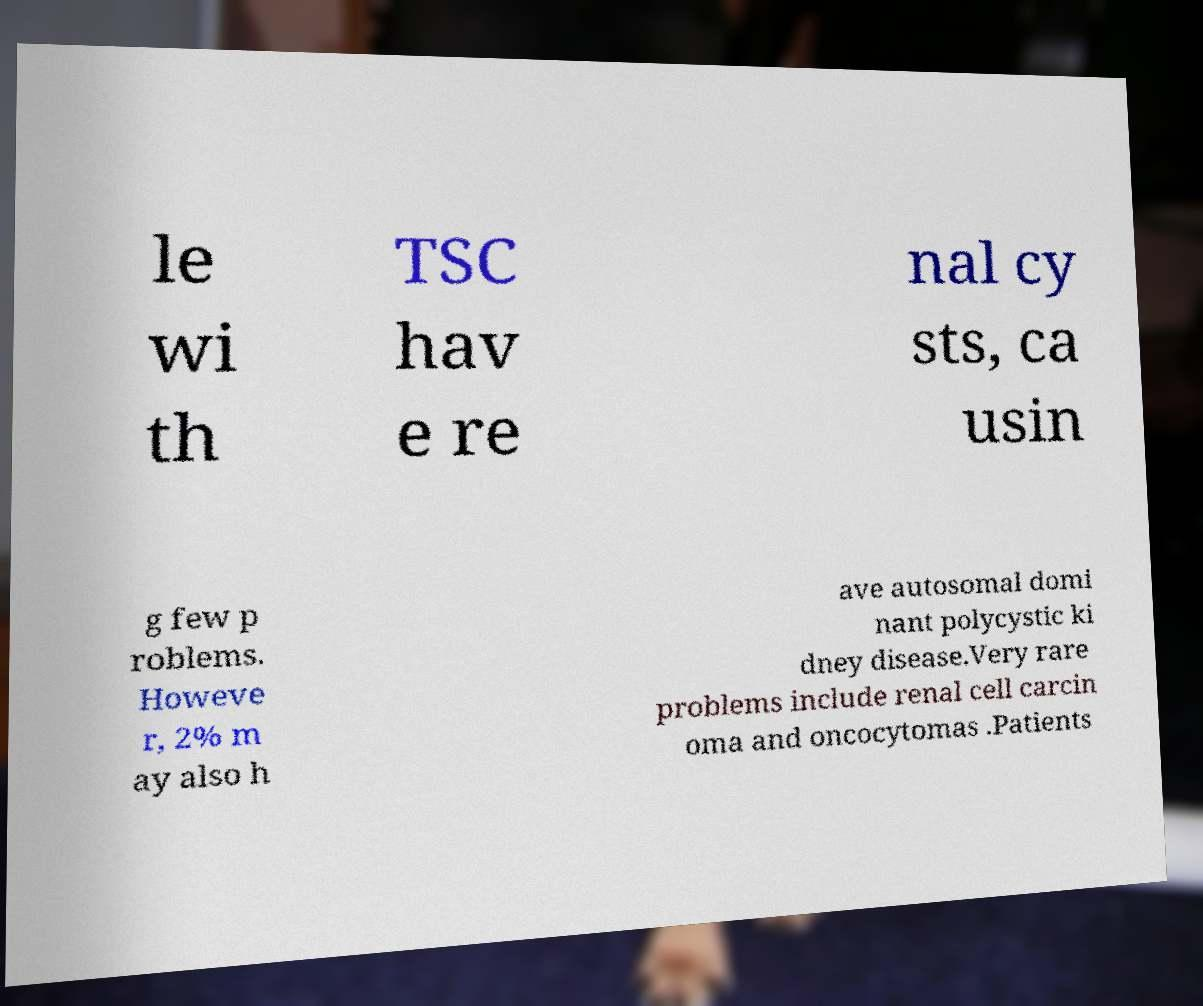I need the written content from this picture converted into text. Can you do that? le wi th TSC hav e re nal cy sts, ca usin g few p roblems. Howeve r, 2% m ay also h ave autosomal domi nant polycystic ki dney disease.Very rare problems include renal cell carcin oma and oncocytomas .Patients 